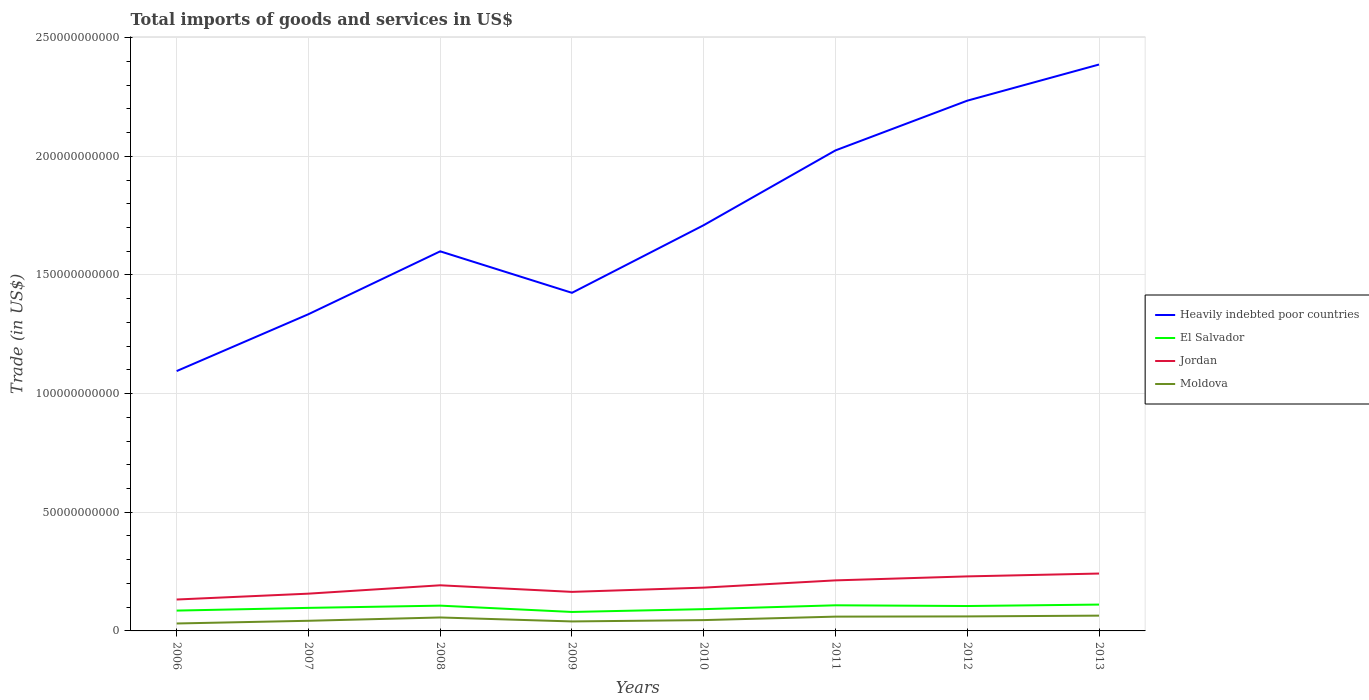Does the line corresponding to Heavily indebted poor countries intersect with the line corresponding to El Salvador?
Offer a terse response. No. Across all years, what is the maximum total imports of goods and services in Moldova?
Offer a very short reply. 3.13e+09. What is the total total imports of goods and services in Moldova in the graph?
Ensure brevity in your answer.  2.78e+08. What is the difference between the highest and the second highest total imports of goods and services in Jordan?
Your response must be concise. 1.09e+1. How many lines are there?
Offer a terse response. 4. How many years are there in the graph?
Provide a succinct answer. 8. Are the values on the major ticks of Y-axis written in scientific E-notation?
Provide a succinct answer. No. Does the graph contain grids?
Your answer should be very brief. Yes. Where does the legend appear in the graph?
Offer a very short reply. Center right. What is the title of the graph?
Provide a short and direct response. Total imports of goods and services in US$. Does "Middle East & North Africa (developing only)" appear as one of the legend labels in the graph?
Provide a succinct answer. No. What is the label or title of the Y-axis?
Provide a succinct answer. Trade (in US$). What is the Trade (in US$) in Heavily indebted poor countries in 2006?
Give a very brief answer. 1.09e+11. What is the Trade (in US$) in El Salvador in 2006?
Offer a very short reply. 8.56e+09. What is the Trade (in US$) of Jordan in 2006?
Your answer should be very brief. 1.32e+1. What is the Trade (in US$) in Moldova in 2006?
Provide a short and direct response. 3.13e+09. What is the Trade (in US$) in Heavily indebted poor countries in 2007?
Your answer should be very brief. 1.33e+11. What is the Trade (in US$) in El Salvador in 2007?
Your answer should be compact. 9.71e+09. What is the Trade (in US$) in Jordan in 2007?
Make the answer very short. 1.57e+1. What is the Trade (in US$) of Moldova in 2007?
Ensure brevity in your answer.  4.28e+09. What is the Trade (in US$) in Heavily indebted poor countries in 2008?
Your response must be concise. 1.60e+11. What is the Trade (in US$) of El Salvador in 2008?
Offer a very short reply. 1.07e+1. What is the Trade (in US$) in Jordan in 2008?
Your response must be concise. 1.92e+1. What is the Trade (in US$) of Moldova in 2008?
Offer a very short reply. 5.67e+09. What is the Trade (in US$) of Heavily indebted poor countries in 2009?
Offer a very short reply. 1.42e+11. What is the Trade (in US$) of El Salvador in 2009?
Provide a succinct answer. 7.99e+09. What is the Trade (in US$) of Jordan in 2009?
Your answer should be very brief. 1.65e+1. What is the Trade (in US$) in Moldova in 2009?
Ensure brevity in your answer.  4.00e+09. What is the Trade (in US$) of Heavily indebted poor countries in 2010?
Give a very brief answer. 1.71e+11. What is the Trade (in US$) of El Salvador in 2010?
Offer a terse response. 9.18e+09. What is the Trade (in US$) in Jordan in 2010?
Offer a very short reply. 1.82e+1. What is the Trade (in US$) in Moldova in 2010?
Offer a very short reply. 4.56e+09. What is the Trade (in US$) of Heavily indebted poor countries in 2011?
Keep it short and to the point. 2.02e+11. What is the Trade (in US$) in El Salvador in 2011?
Your response must be concise. 1.08e+1. What is the Trade (in US$) of Jordan in 2011?
Your answer should be very brief. 2.13e+1. What is the Trade (in US$) in Moldova in 2011?
Offer a very short reply. 6.02e+09. What is the Trade (in US$) of Heavily indebted poor countries in 2012?
Make the answer very short. 2.23e+11. What is the Trade (in US$) in El Salvador in 2012?
Offer a very short reply. 1.05e+1. What is the Trade (in US$) in Jordan in 2012?
Give a very brief answer. 2.30e+1. What is the Trade (in US$) of Moldova in 2012?
Your answer should be compact. 6.11e+09. What is the Trade (in US$) of Heavily indebted poor countries in 2013?
Your answer should be very brief. 2.39e+11. What is the Trade (in US$) of El Salvador in 2013?
Your answer should be compact. 1.11e+1. What is the Trade (in US$) in Jordan in 2013?
Give a very brief answer. 2.42e+1. What is the Trade (in US$) in Moldova in 2013?
Ensure brevity in your answer.  6.44e+09. Across all years, what is the maximum Trade (in US$) of Heavily indebted poor countries?
Offer a very short reply. 2.39e+11. Across all years, what is the maximum Trade (in US$) in El Salvador?
Your response must be concise. 1.11e+1. Across all years, what is the maximum Trade (in US$) of Jordan?
Your answer should be very brief. 2.42e+1. Across all years, what is the maximum Trade (in US$) in Moldova?
Ensure brevity in your answer.  6.44e+09. Across all years, what is the minimum Trade (in US$) in Heavily indebted poor countries?
Provide a short and direct response. 1.09e+11. Across all years, what is the minimum Trade (in US$) in El Salvador?
Make the answer very short. 7.99e+09. Across all years, what is the minimum Trade (in US$) in Jordan?
Offer a terse response. 1.32e+1. Across all years, what is the minimum Trade (in US$) of Moldova?
Ensure brevity in your answer.  3.13e+09. What is the total Trade (in US$) of Heavily indebted poor countries in the graph?
Offer a very short reply. 1.38e+12. What is the total Trade (in US$) in El Salvador in the graph?
Your answer should be very brief. 7.85e+1. What is the total Trade (in US$) of Jordan in the graph?
Offer a very short reply. 1.51e+11. What is the total Trade (in US$) in Moldova in the graph?
Keep it short and to the point. 4.02e+1. What is the difference between the Trade (in US$) in Heavily indebted poor countries in 2006 and that in 2007?
Your answer should be compact. -2.40e+1. What is the difference between the Trade (in US$) in El Salvador in 2006 and that in 2007?
Your answer should be compact. -1.15e+09. What is the difference between the Trade (in US$) in Jordan in 2006 and that in 2007?
Give a very brief answer. -2.47e+09. What is the difference between the Trade (in US$) of Moldova in 2006 and that in 2007?
Keep it short and to the point. -1.14e+09. What is the difference between the Trade (in US$) in Heavily indebted poor countries in 2006 and that in 2008?
Your answer should be compact. -5.05e+1. What is the difference between the Trade (in US$) in El Salvador in 2006 and that in 2008?
Provide a succinct answer. -2.09e+09. What is the difference between the Trade (in US$) in Jordan in 2006 and that in 2008?
Your answer should be compact. -6.00e+09. What is the difference between the Trade (in US$) in Moldova in 2006 and that in 2008?
Give a very brief answer. -2.54e+09. What is the difference between the Trade (in US$) of Heavily indebted poor countries in 2006 and that in 2009?
Make the answer very short. -3.30e+1. What is the difference between the Trade (in US$) of El Salvador in 2006 and that in 2009?
Give a very brief answer. 5.74e+08. What is the difference between the Trade (in US$) in Jordan in 2006 and that in 2009?
Ensure brevity in your answer.  -3.22e+09. What is the difference between the Trade (in US$) in Moldova in 2006 and that in 2009?
Provide a short and direct response. -8.65e+08. What is the difference between the Trade (in US$) in Heavily indebted poor countries in 2006 and that in 2010?
Ensure brevity in your answer.  -6.15e+1. What is the difference between the Trade (in US$) of El Salvador in 2006 and that in 2010?
Make the answer very short. -6.12e+08. What is the difference between the Trade (in US$) of Jordan in 2006 and that in 2010?
Offer a very short reply. -5.01e+09. What is the difference between the Trade (in US$) in Moldova in 2006 and that in 2010?
Give a very brief answer. -1.43e+09. What is the difference between the Trade (in US$) in Heavily indebted poor countries in 2006 and that in 2011?
Your answer should be compact. -9.30e+1. What is the difference between the Trade (in US$) of El Salvador in 2006 and that in 2011?
Offer a very short reply. -2.23e+09. What is the difference between the Trade (in US$) in Jordan in 2006 and that in 2011?
Your answer should be compact. -8.07e+09. What is the difference between the Trade (in US$) of Moldova in 2006 and that in 2011?
Offer a very short reply. -2.89e+09. What is the difference between the Trade (in US$) of Heavily indebted poor countries in 2006 and that in 2012?
Give a very brief answer. -1.14e+11. What is the difference between the Trade (in US$) of El Salvador in 2006 and that in 2012?
Provide a succinct answer. -1.93e+09. What is the difference between the Trade (in US$) in Jordan in 2006 and that in 2012?
Your answer should be very brief. -9.74e+09. What is the difference between the Trade (in US$) of Moldova in 2006 and that in 2012?
Your answer should be very brief. -2.98e+09. What is the difference between the Trade (in US$) in Heavily indebted poor countries in 2006 and that in 2013?
Provide a succinct answer. -1.29e+11. What is the difference between the Trade (in US$) in El Salvador in 2006 and that in 2013?
Your answer should be compact. -2.53e+09. What is the difference between the Trade (in US$) of Jordan in 2006 and that in 2013?
Provide a succinct answer. -1.09e+1. What is the difference between the Trade (in US$) of Moldova in 2006 and that in 2013?
Keep it short and to the point. -3.30e+09. What is the difference between the Trade (in US$) in Heavily indebted poor countries in 2007 and that in 2008?
Ensure brevity in your answer.  -2.65e+1. What is the difference between the Trade (in US$) in El Salvador in 2007 and that in 2008?
Keep it short and to the point. -9.41e+08. What is the difference between the Trade (in US$) in Jordan in 2007 and that in 2008?
Keep it short and to the point. -3.53e+09. What is the difference between the Trade (in US$) in Moldova in 2007 and that in 2008?
Offer a very short reply. -1.39e+09. What is the difference between the Trade (in US$) of Heavily indebted poor countries in 2007 and that in 2009?
Ensure brevity in your answer.  -9.01e+09. What is the difference between the Trade (in US$) in El Salvador in 2007 and that in 2009?
Provide a succinct answer. 1.72e+09. What is the difference between the Trade (in US$) in Jordan in 2007 and that in 2009?
Your answer should be compact. -7.53e+08. What is the difference between the Trade (in US$) in Moldova in 2007 and that in 2009?
Give a very brief answer. 2.78e+08. What is the difference between the Trade (in US$) of Heavily indebted poor countries in 2007 and that in 2010?
Provide a succinct answer. -3.75e+1. What is the difference between the Trade (in US$) of El Salvador in 2007 and that in 2010?
Ensure brevity in your answer.  5.33e+08. What is the difference between the Trade (in US$) in Jordan in 2007 and that in 2010?
Offer a terse response. -2.54e+09. What is the difference between the Trade (in US$) of Moldova in 2007 and that in 2010?
Offer a terse response. -2.89e+08. What is the difference between the Trade (in US$) of Heavily indebted poor countries in 2007 and that in 2011?
Provide a succinct answer. -6.90e+1. What is the difference between the Trade (in US$) of El Salvador in 2007 and that in 2011?
Offer a terse response. -1.09e+09. What is the difference between the Trade (in US$) in Jordan in 2007 and that in 2011?
Your response must be concise. -5.60e+09. What is the difference between the Trade (in US$) in Moldova in 2007 and that in 2011?
Ensure brevity in your answer.  -1.75e+09. What is the difference between the Trade (in US$) of Heavily indebted poor countries in 2007 and that in 2012?
Make the answer very short. -9.00e+1. What is the difference between the Trade (in US$) of El Salvador in 2007 and that in 2012?
Provide a succinct answer. -7.87e+08. What is the difference between the Trade (in US$) in Jordan in 2007 and that in 2012?
Offer a very short reply. -7.28e+09. What is the difference between the Trade (in US$) of Moldova in 2007 and that in 2012?
Give a very brief answer. -1.84e+09. What is the difference between the Trade (in US$) in Heavily indebted poor countries in 2007 and that in 2013?
Offer a terse response. -1.05e+11. What is the difference between the Trade (in US$) in El Salvador in 2007 and that in 2013?
Keep it short and to the point. -1.39e+09. What is the difference between the Trade (in US$) of Jordan in 2007 and that in 2013?
Offer a very short reply. -8.47e+09. What is the difference between the Trade (in US$) of Moldova in 2007 and that in 2013?
Your answer should be compact. -2.16e+09. What is the difference between the Trade (in US$) in Heavily indebted poor countries in 2008 and that in 2009?
Offer a terse response. 1.75e+1. What is the difference between the Trade (in US$) of El Salvador in 2008 and that in 2009?
Give a very brief answer. 2.66e+09. What is the difference between the Trade (in US$) of Jordan in 2008 and that in 2009?
Provide a succinct answer. 2.77e+09. What is the difference between the Trade (in US$) of Moldova in 2008 and that in 2009?
Make the answer very short. 1.67e+09. What is the difference between the Trade (in US$) in Heavily indebted poor countries in 2008 and that in 2010?
Provide a short and direct response. -1.10e+1. What is the difference between the Trade (in US$) in El Salvador in 2008 and that in 2010?
Provide a short and direct response. 1.47e+09. What is the difference between the Trade (in US$) of Jordan in 2008 and that in 2010?
Keep it short and to the point. 9.86e+08. What is the difference between the Trade (in US$) in Moldova in 2008 and that in 2010?
Ensure brevity in your answer.  1.10e+09. What is the difference between the Trade (in US$) in Heavily indebted poor countries in 2008 and that in 2011?
Provide a succinct answer. -4.25e+1. What is the difference between the Trade (in US$) in El Salvador in 2008 and that in 2011?
Make the answer very short. -1.46e+08. What is the difference between the Trade (in US$) in Jordan in 2008 and that in 2011?
Provide a succinct answer. -2.07e+09. What is the difference between the Trade (in US$) in Moldova in 2008 and that in 2011?
Give a very brief answer. -3.54e+08. What is the difference between the Trade (in US$) in Heavily indebted poor countries in 2008 and that in 2012?
Offer a terse response. -6.35e+1. What is the difference between the Trade (in US$) of El Salvador in 2008 and that in 2012?
Provide a succinct answer. 1.55e+08. What is the difference between the Trade (in US$) of Jordan in 2008 and that in 2012?
Offer a terse response. -3.75e+09. What is the difference between the Trade (in US$) of Moldova in 2008 and that in 2012?
Your response must be concise. -4.47e+08. What is the difference between the Trade (in US$) in Heavily indebted poor countries in 2008 and that in 2013?
Provide a succinct answer. -7.87e+1. What is the difference between the Trade (in US$) of El Salvador in 2008 and that in 2013?
Provide a short and direct response. -4.48e+08. What is the difference between the Trade (in US$) in Jordan in 2008 and that in 2013?
Your response must be concise. -4.95e+09. What is the difference between the Trade (in US$) of Moldova in 2008 and that in 2013?
Give a very brief answer. -7.68e+08. What is the difference between the Trade (in US$) in Heavily indebted poor countries in 2009 and that in 2010?
Give a very brief answer. -2.85e+1. What is the difference between the Trade (in US$) in El Salvador in 2009 and that in 2010?
Your response must be concise. -1.19e+09. What is the difference between the Trade (in US$) of Jordan in 2009 and that in 2010?
Keep it short and to the point. -1.79e+09. What is the difference between the Trade (in US$) in Moldova in 2009 and that in 2010?
Your response must be concise. -5.67e+08. What is the difference between the Trade (in US$) in Heavily indebted poor countries in 2009 and that in 2011?
Keep it short and to the point. -6.00e+1. What is the difference between the Trade (in US$) of El Salvador in 2009 and that in 2011?
Keep it short and to the point. -2.81e+09. What is the difference between the Trade (in US$) in Jordan in 2009 and that in 2011?
Provide a short and direct response. -4.85e+09. What is the difference between the Trade (in US$) in Moldova in 2009 and that in 2011?
Your response must be concise. -2.02e+09. What is the difference between the Trade (in US$) of Heavily indebted poor countries in 2009 and that in 2012?
Ensure brevity in your answer.  -8.10e+1. What is the difference between the Trade (in US$) of El Salvador in 2009 and that in 2012?
Your answer should be very brief. -2.51e+09. What is the difference between the Trade (in US$) in Jordan in 2009 and that in 2012?
Your answer should be compact. -6.52e+09. What is the difference between the Trade (in US$) in Moldova in 2009 and that in 2012?
Offer a very short reply. -2.12e+09. What is the difference between the Trade (in US$) in Heavily indebted poor countries in 2009 and that in 2013?
Make the answer very short. -9.62e+1. What is the difference between the Trade (in US$) of El Salvador in 2009 and that in 2013?
Provide a succinct answer. -3.11e+09. What is the difference between the Trade (in US$) of Jordan in 2009 and that in 2013?
Ensure brevity in your answer.  -7.72e+09. What is the difference between the Trade (in US$) of Moldova in 2009 and that in 2013?
Offer a terse response. -2.44e+09. What is the difference between the Trade (in US$) of Heavily indebted poor countries in 2010 and that in 2011?
Your answer should be very brief. -3.15e+1. What is the difference between the Trade (in US$) of El Salvador in 2010 and that in 2011?
Make the answer very short. -1.62e+09. What is the difference between the Trade (in US$) of Jordan in 2010 and that in 2011?
Provide a short and direct response. -3.06e+09. What is the difference between the Trade (in US$) in Moldova in 2010 and that in 2011?
Offer a terse response. -1.46e+09. What is the difference between the Trade (in US$) of Heavily indebted poor countries in 2010 and that in 2012?
Your answer should be very brief. -5.25e+1. What is the difference between the Trade (in US$) of El Salvador in 2010 and that in 2012?
Give a very brief answer. -1.32e+09. What is the difference between the Trade (in US$) of Jordan in 2010 and that in 2012?
Your answer should be very brief. -4.73e+09. What is the difference between the Trade (in US$) of Moldova in 2010 and that in 2012?
Provide a succinct answer. -1.55e+09. What is the difference between the Trade (in US$) in Heavily indebted poor countries in 2010 and that in 2013?
Your answer should be compact. -6.77e+1. What is the difference between the Trade (in US$) in El Salvador in 2010 and that in 2013?
Offer a very short reply. -1.92e+09. What is the difference between the Trade (in US$) of Jordan in 2010 and that in 2013?
Make the answer very short. -5.93e+09. What is the difference between the Trade (in US$) of Moldova in 2010 and that in 2013?
Keep it short and to the point. -1.87e+09. What is the difference between the Trade (in US$) in Heavily indebted poor countries in 2011 and that in 2012?
Your response must be concise. -2.09e+1. What is the difference between the Trade (in US$) in El Salvador in 2011 and that in 2012?
Your answer should be very brief. 3.01e+08. What is the difference between the Trade (in US$) of Jordan in 2011 and that in 2012?
Offer a terse response. -1.67e+09. What is the difference between the Trade (in US$) of Moldova in 2011 and that in 2012?
Offer a terse response. -9.38e+07. What is the difference between the Trade (in US$) in Heavily indebted poor countries in 2011 and that in 2013?
Make the answer very short. -3.62e+1. What is the difference between the Trade (in US$) of El Salvador in 2011 and that in 2013?
Your response must be concise. -3.01e+08. What is the difference between the Trade (in US$) in Jordan in 2011 and that in 2013?
Your response must be concise. -2.87e+09. What is the difference between the Trade (in US$) in Moldova in 2011 and that in 2013?
Ensure brevity in your answer.  -4.15e+08. What is the difference between the Trade (in US$) of Heavily indebted poor countries in 2012 and that in 2013?
Your response must be concise. -1.52e+1. What is the difference between the Trade (in US$) in El Salvador in 2012 and that in 2013?
Offer a very short reply. -6.02e+08. What is the difference between the Trade (in US$) in Jordan in 2012 and that in 2013?
Offer a terse response. -1.20e+09. What is the difference between the Trade (in US$) in Moldova in 2012 and that in 2013?
Provide a succinct answer. -3.21e+08. What is the difference between the Trade (in US$) of Heavily indebted poor countries in 2006 and the Trade (in US$) of El Salvador in 2007?
Your response must be concise. 9.98e+1. What is the difference between the Trade (in US$) in Heavily indebted poor countries in 2006 and the Trade (in US$) in Jordan in 2007?
Provide a short and direct response. 9.38e+1. What is the difference between the Trade (in US$) in Heavily indebted poor countries in 2006 and the Trade (in US$) in Moldova in 2007?
Ensure brevity in your answer.  1.05e+11. What is the difference between the Trade (in US$) of El Salvador in 2006 and the Trade (in US$) of Jordan in 2007?
Provide a succinct answer. -7.14e+09. What is the difference between the Trade (in US$) in El Salvador in 2006 and the Trade (in US$) in Moldova in 2007?
Your response must be concise. 4.29e+09. What is the difference between the Trade (in US$) in Jordan in 2006 and the Trade (in US$) in Moldova in 2007?
Give a very brief answer. 8.96e+09. What is the difference between the Trade (in US$) of Heavily indebted poor countries in 2006 and the Trade (in US$) of El Salvador in 2008?
Your response must be concise. 9.88e+1. What is the difference between the Trade (in US$) in Heavily indebted poor countries in 2006 and the Trade (in US$) in Jordan in 2008?
Offer a very short reply. 9.03e+1. What is the difference between the Trade (in US$) in Heavily indebted poor countries in 2006 and the Trade (in US$) in Moldova in 2008?
Keep it short and to the point. 1.04e+11. What is the difference between the Trade (in US$) of El Salvador in 2006 and the Trade (in US$) of Jordan in 2008?
Make the answer very short. -1.07e+1. What is the difference between the Trade (in US$) of El Salvador in 2006 and the Trade (in US$) of Moldova in 2008?
Provide a short and direct response. 2.90e+09. What is the difference between the Trade (in US$) in Jordan in 2006 and the Trade (in US$) in Moldova in 2008?
Provide a succinct answer. 7.56e+09. What is the difference between the Trade (in US$) of Heavily indebted poor countries in 2006 and the Trade (in US$) of El Salvador in 2009?
Make the answer very short. 1.02e+11. What is the difference between the Trade (in US$) in Heavily indebted poor countries in 2006 and the Trade (in US$) in Jordan in 2009?
Give a very brief answer. 9.30e+1. What is the difference between the Trade (in US$) in Heavily indebted poor countries in 2006 and the Trade (in US$) in Moldova in 2009?
Offer a very short reply. 1.05e+11. What is the difference between the Trade (in US$) of El Salvador in 2006 and the Trade (in US$) of Jordan in 2009?
Your answer should be compact. -7.89e+09. What is the difference between the Trade (in US$) of El Salvador in 2006 and the Trade (in US$) of Moldova in 2009?
Your answer should be compact. 4.57e+09. What is the difference between the Trade (in US$) in Jordan in 2006 and the Trade (in US$) in Moldova in 2009?
Provide a succinct answer. 9.23e+09. What is the difference between the Trade (in US$) in Heavily indebted poor countries in 2006 and the Trade (in US$) in El Salvador in 2010?
Your answer should be very brief. 1.00e+11. What is the difference between the Trade (in US$) of Heavily indebted poor countries in 2006 and the Trade (in US$) of Jordan in 2010?
Make the answer very short. 9.13e+1. What is the difference between the Trade (in US$) in Heavily indebted poor countries in 2006 and the Trade (in US$) in Moldova in 2010?
Offer a terse response. 1.05e+11. What is the difference between the Trade (in US$) of El Salvador in 2006 and the Trade (in US$) of Jordan in 2010?
Your answer should be compact. -9.68e+09. What is the difference between the Trade (in US$) of El Salvador in 2006 and the Trade (in US$) of Moldova in 2010?
Make the answer very short. 4.00e+09. What is the difference between the Trade (in US$) of Jordan in 2006 and the Trade (in US$) of Moldova in 2010?
Ensure brevity in your answer.  8.67e+09. What is the difference between the Trade (in US$) in Heavily indebted poor countries in 2006 and the Trade (in US$) in El Salvador in 2011?
Offer a very short reply. 9.87e+1. What is the difference between the Trade (in US$) of Heavily indebted poor countries in 2006 and the Trade (in US$) of Jordan in 2011?
Your answer should be compact. 8.82e+1. What is the difference between the Trade (in US$) of Heavily indebted poor countries in 2006 and the Trade (in US$) of Moldova in 2011?
Ensure brevity in your answer.  1.03e+11. What is the difference between the Trade (in US$) of El Salvador in 2006 and the Trade (in US$) of Jordan in 2011?
Keep it short and to the point. -1.27e+1. What is the difference between the Trade (in US$) of El Salvador in 2006 and the Trade (in US$) of Moldova in 2011?
Offer a very short reply. 2.54e+09. What is the difference between the Trade (in US$) of Jordan in 2006 and the Trade (in US$) of Moldova in 2011?
Offer a terse response. 7.21e+09. What is the difference between the Trade (in US$) in Heavily indebted poor countries in 2006 and the Trade (in US$) in El Salvador in 2012?
Keep it short and to the point. 9.90e+1. What is the difference between the Trade (in US$) of Heavily indebted poor countries in 2006 and the Trade (in US$) of Jordan in 2012?
Give a very brief answer. 8.65e+1. What is the difference between the Trade (in US$) in Heavily indebted poor countries in 2006 and the Trade (in US$) in Moldova in 2012?
Your answer should be compact. 1.03e+11. What is the difference between the Trade (in US$) of El Salvador in 2006 and the Trade (in US$) of Jordan in 2012?
Make the answer very short. -1.44e+1. What is the difference between the Trade (in US$) of El Salvador in 2006 and the Trade (in US$) of Moldova in 2012?
Make the answer very short. 2.45e+09. What is the difference between the Trade (in US$) in Jordan in 2006 and the Trade (in US$) in Moldova in 2012?
Your answer should be very brief. 7.12e+09. What is the difference between the Trade (in US$) of Heavily indebted poor countries in 2006 and the Trade (in US$) of El Salvador in 2013?
Provide a short and direct response. 9.84e+1. What is the difference between the Trade (in US$) in Heavily indebted poor countries in 2006 and the Trade (in US$) in Jordan in 2013?
Keep it short and to the point. 8.53e+1. What is the difference between the Trade (in US$) in Heavily indebted poor countries in 2006 and the Trade (in US$) in Moldova in 2013?
Give a very brief answer. 1.03e+11. What is the difference between the Trade (in US$) of El Salvador in 2006 and the Trade (in US$) of Jordan in 2013?
Keep it short and to the point. -1.56e+1. What is the difference between the Trade (in US$) of El Salvador in 2006 and the Trade (in US$) of Moldova in 2013?
Give a very brief answer. 2.13e+09. What is the difference between the Trade (in US$) in Jordan in 2006 and the Trade (in US$) in Moldova in 2013?
Provide a short and direct response. 6.80e+09. What is the difference between the Trade (in US$) in Heavily indebted poor countries in 2007 and the Trade (in US$) in El Salvador in 2008?
Provide a short and direct response. 1.23e+11. What is the difference between the Trade (in US$) in Heavily indebted poor countries in 2007 and the Trade (in US$) in Jordan in 2008?
Give a very brief answer. 1.14e+11. What is the difference between the Trade (in US$) of Heavily indebted poor countries in 2007 and the Trade (in US$) of Moldova in 2008?
Offer a terse response. 1.28e+11. What is the difference between the Trade (in US$) of El Salvador in 2007 and the Trade (in US$) of Jordan in 2008?
Make the answer very short. -9.52e+09. What is the difference between the Trade (in US$) in El Salvador in 2007 and the Trade (in US$) in Moldova in 2008?
Offer a terse response. 4.04e+09. What is the difference between the Trade (in US$) of Jordan in 2007 and the Trade (in US$) of Moldova in 2008?
Your answer should be compact. 1.00e+1. What is the difference between the Trade (in US$) of Heavily indebted poor countries in 2007 and the Trade (in US$) of El Salvador in 2009?
Your answer should be very brief. 1.25e+11. What is the difference between the Trade (in US$) in Heavily indebted poor countries in 2007 and the Trade (in US$) in Jordan in 2009?
Ensure brevity in your answer.  1.17e+11. What is the difference between the Trade (in US$) of Heavily indebted poor countries in 2007 and the Trade (in US$) of Moldova in 2009?
Make the answer very short. 1.29e+11. What is the difference between the Trade (in US$) in El Salvador in 2007 and the Trade (in US$) in Jordan in 2009?
Provide a short and direct response. -6.74e+09. What is the difference between the Trade (in US$) in El Salvador in 2007 and the Trade (in US$) in Moldova in 2009?
Your response must be concise. 5.71e+09. What is the difference between the Trade (in US$) of Jordan in 2007 and the Trade (in US$) of Moldova in 2009?
Make the answer very short. 1.17e+1. What is the difference between the Trade (in US$) of Heavily indebted poor countries in 2007 and the Trade (in US$) of El Salvador in 2010?
Make the answer very short. 1.24e+11. What is the difference between the Trade (in US$) in Heavily indebted poor countries in 2007 and the Trade (in US$) in Jordan in 2010?
Give a very brief answer. 1.15e+11. What is the difference between the Trade (in US$) of Heavily indebted poor countries in 2007 and the Trade (in US$) of Moldova in 2010?
Offer a terse response. 1.29e+11. What is the difference between the Trade (in US$) of El Salvador in 2007 and the Trade (in US$) of Jordan in 2010?
Your response must be concise. -8.53e+09. What is the difference between the Trade (in US$) of El Salvador in 2007 and the Trade (in US$) of Moldova in 2010?
Provide a succinct answer. 5.14e+09. What is the difference between the Trade (in US$) of Jordan in 2007 and the Trade (in US$) of Moldova in 2010?
Ensure brevity in your answer.  1.11e+1. What is the difference between the Trade (in US$) of Heavily indebted poor countries in 2007 and the Trade (in US$) of El Salvador in 2011?
Make the answer very short. 1.23e+11. What is the difference between the Trade (in US$) of Heavily indebted poor countries in 2007 and the Trade (in US$) of Jordan in 2011?
Offer a terse response. 1.12e+11. What is the difference between the Trade (in US$) of Heavily indebted poor countries in 2007 and the Trade (in US$) of Moldova in 2011?
Offer a terse response. 1.27e+11. What is the difference between the Trade (in US$) of El Salvador in 2007 and the Trade (in US$) of Jordan in 2011?
Make the answer very short. -1.16e+1. What is the difference between the Trade (in US$) in El Salvador in 2007 and the Trade (in US$) in Moldova in 2011?
Provide a short and direct response. 3.69e+09. What is the difference between the Trade (in US$) in Jordan in 2007 and the Trade (in US$) in Moldova in 2011?
Provide a short and direct response. 9.68e+09. What is the difference between the Trade (in US$) in Heavily indebted poor countries in 2007 and the Trade (in US$) in El Salvador in 2012?
Your answer should be compact. 1.23e+11. What is the difference between the Trade (in US$) in Heavily indebted poor countries in 2007 and the Trade (in US$) in Jordan in 2012?
Your answer should be compact. 1.10e+11. What is the difference between the Trade (in US$) of Heavily indebted poor countries in 2007 and the Trade (in US$) of Moldova in 2012?
Offer a terse response. 1.27e+11. What is the difference between the Trade (in US$) of El Salvador in 2007 and the Trade (in US$) of Jordan in 2012?
Ensure brevity in your answer.  -1.33e+1. What is the difference between the Trade (in US$) of El Salvador in 2007 and the Trade (in US$) of Moldova in 2012?
Offer a terse response. 3.59e+09. What is the difference between the Trade (in US$) in Jordan in 2007 and the Trade (in US$) in Moldova in 2012?
Ensure brevity in your answer.  9.59e+09. What is the difference between the Trade (in US$) of Heavily indebted poor countries in 2007 and the Trade (in US$) of El Salvador in 2013?
Make the answer very short. 1.22e+11. What is the difference between the Trade (in US$) of Heavily indebted poor countries in 2007 and the Trade (in US$) of Jordan in 2013?
Ensure brevity in your answer.  1.09e+11. What is the difference between the Trade (in US$) of Heavily indebted poor countries in 2007 and the Trade (in US$) of Moldova in 2013?
Offer a very short reply. 1.27e+11. What is the difference between the Trade (in US$) in El Salvador in 2007 and the Trade (in US$) in Jordan in 2013?
Offer a terse response. -1.45e+1. What is the difference between the Trade (in US$) of El Salvador in 2007 and the Trade (in US$) of Moldova in 2013?
Your response must be concise. 3.27e+09. What is the difference between the Trade (in US$) in Jordan in 2007 and the Trade (in US$) in Moldova in 2013?
Keep it short and to the point. 9.26e+09. What is the difference between the Trade (in US$) of Heavily indebted poor countries in 2008 and the Trade (in US$) of El Salvador in 2009?
Provide a short and direct response. 1.52e+11. What is the difference between the Trade (in US$) in Heavily indebted poor countries in 2008 and the Trade (in US$) in Jordan in 2009?
Offer a terse response. 1.43e+11. What is the difference between the Trade (in US$) in Heavily indebted poor countries in 2008 and the Trade (in US$) in Moldova in 2009?
Provide a succinct answer. 1.56e+11. What is the difference between the Trade (in US$) in El Salvador in 2008 and the Trade (in US$) in Jordan in 2009?
Your response must be concise. -5.80e+09. What is the difference between the Trade (in US$) in El Salvador in 2008 and the Trade (in US$) in Moldova in 2009?
Your answer should be compact. 6.65e+09. What is the difference between the Trade (in US$) of Jordan in 2008 and the Trade (in US$) of Moldova in 2009?
Your answer should be compact. 1.52e+1. What is the difference between the Trade (in US$) in Heavily indebted poor countries in 2008 and the Trade (in US$) in El Salvador in 2010?
Your answer should be compact. 1.51e+11. What is the difference between the Trade (in US$) of Heavily indebted poor countries in 2008 and the Trade (in US$) of Jordan in 2010?
Your answer should be compact. 1.42e+11. What is the difference between the Trade (in US$) in Heavily indebted poor countries in 2008 and the Trade (in US$) in Moldova in 2010?
Offer a very short reply. 1.55e+11. What is the difference between the Trade (in US$) in El Salvador in 2008 and the Trade (in US$) in Jordan in 2010?
Your response must be concise. -7.59e+09. What is the difference between the Trade (in US$) in El Salvador in 2008 and the Trade (in US$) in Moldova in 2010?
Give a very brief answer. 6.09e+09. What is the difference between the Trade (in US$) in Jordan in 2008 and the Trade (in US$) in Moldova in 2010?
Keep it short and to the point. 1.47e+1. What is the difference between the Trade (in US$) in Heavily indebted poor countries in 2008 and the Trade (in US$) in El Salvador in 2011?
Give a very brief answer. 1.49e+11. What is the difference between the Trade (in US$) in Heavily indebted poor countries in 2008 and the Trade (in US$) in Jordan in 2011?
Provide a succinct answer. 1.39e+11. What is the difference between the Trade (in US$) of Heavily indebted poor countries in 2008 and the Trade (in US$) of Moldova in 2011?
Your response must be concise. 1.54e+11. What is the difference between the Trade (in US$) in El Salvador in 2008 and the Trade (in US$) in Jordan in 2011?
Offer a terse response. -1.07e+1. What is the difference between the Trade (in US$) of El Salvador in 2008 and the Trade (in US$) of Moldova in 2011?
Keep it short and to the point. 4.63e+09. What is the difference between the Trade (in US$) in Jordan in 2008 and the Trade (in US$) in Moldova in 2011?
Provide a succinct answer. 1.32e+1. What is the difference between the Trade (in US$) of Heavily indebted poor countries in 2008 and the Trade (in US$) of El Salvador in 2012?
Provide a succinct answer. 1.49e+11. What is the difference between the Trade (in US$) in Heavily indebted poor countries in 2008 and the Trade (in US$) in Jordan in 2012?
Offer a terse response. 1.37e+11. What is the difference between the Trade (in US$) in Heavily indebted poor countries in 2008 and the Trade (in US$) in Moldova in 2012?
Your answer should be compact. 1.54e+11. What is the difference between the Trade (in US$) of El Salvador in 2008 and the Trade (in US$) of Jordan in 2012?
Provide a succinct answer. -1.23e+1. What is the difference between the Trade (in US$) in El Salvador in 2008 and the Trade (in US$) in Moldova in 2012?
Make the answer very short. 4.54e+09. What is the difference between the Trade (in US$) of Jordan in 2008 and the Trade (in US$) of Moldova in 2012?
Give a very brief answer. 1.31e+1. What is the difference between the Trade (in US$) in Heavily indebted poor countries in 2008 and the Trade (in US$) in El Salvador in 2013?
Provide a short and direct response. 1.49e+11. What is the difference between the Trade (in US$) in Heavily indebted poor countries in 2008 and the Trade (in US$) in Jordan in 2013?
Provide a short and direct response. 1.36e+11. What is the difference between the Trade (in US$) in Heavily indebted poor countries in 2008 and the Trade (in US$) in Moldova in 2013?
Your response must be concise. 1.54e+11. What is the difference between the Trade (in US$) of El Salvador in 2008 and the Trade (in US$) of Jordan in 2013?
Keep it short and to the point. -1.35e+1. What is the difference between the Trade (in US$) in El Salvador in 2008 and the Trade (in US$) in Moldova in 2013?
Provide a succinct answer. 4.22e+09. What is the difference between the Trade (in US$) in Jordan in 2008 and the Trade (in US$) in Moldova in 2013?
Offer a very short reply. 1.28e+1. What is the difference between the Trade (in US$) of Heavily indebted poor countries in 2009 and the Trade (in US$) of El Salvador in 2010?
Your answer should be very brief. 1.33e+11. What is the difference between the Trade (in US$) of Heavily indebted poor countries in 2009 and the Trade (in US$) of Jordan in 2010?
Keep it short and to the point. 1.24e+11. What is the difference between the Trade (in US$) in Heavily indebted poor countries in 2009 and the Trade (in US$) in Moldova in 2010?
Keep it short and to the point. 1.38e+11. What is the difference between the Trade (in US$) of El Salvador in 2009 and the Trade (in US$) of Jordan in 2010?
Offer a terse response. -1.03e+1. What is the difference between the Trade (in US$) of El Salvador in 2009 and the Trade (in US$) of Moldova in 2010?
Your response must be concise. 3.43e+09. What is the difference between the Trade (in US$) in Jordan in 2009 and the Trade (in US$) in Moldova in 2010?
Your response must be concise. 1.19e+1. What is the difference between the Trade (in US$) of Heavily indebted poor countries in 2009 and the Trade (in US$) of El Salvador in 2011?
Provide a succinct answer. 1.32e+11. What is the difference between the Trade (in US$) of Heavily indebted poor countries in 2009 and the Trade (in US$) of Jordan in 2011?
Offer a terse response. 1.21e+11. What is the difference between the Trade (in US$) of Heavily indebted poor countries in 2009 and the Trade (in US$) of Moldova in 2011?
Ensure brevity in your answer.  1.36e+11. What is the difference between the Trade (in US$) in El Salvador in 2009 and the Trade (in US$) in Jordan in 2011?
Provide a succinct answer. -1.33e+1. What is the difference between the Trade (in US$) in El Salvador in 2009 and the Trade (in US$) in Moldova in 2011?
Offer a very short reply. 1.97e+09. What is the difference between the Trade (in US$) in Jordan in 2009 and the Trade (in US$) in Moldova in 2011?
Make the answer very short. 1.04e+1. What is the difference between the Trade (in US$) of Heavily indebted poor countries in 2009 and the Trade (in US$) of El Salvador in 2012?
Provide a succinct answer. 1.32e+11. What is the difference between the Trade (in US$) in Heavily indebted poor countries in 2009 and the Trade (in US$) in Jordan in 2012?
Provide a succinct answer. 1.19e+11. What is the difference between the Trade (in US$) of Heavily indebted poor countries in 2009 and the Trade (in US$) of Moldova in 2012?
Make the answer very short. 1.36e+11. What is the difference between the Trade (in US$) in El Salvador in 2009 and the Trade (in US$) in Jordan in 2012?
Provide a succinct answer. -1.50e+1. What is the difference between the Trade (in US$) in El Salvador in 2009 and the Trade (in US$) in Moldova in 2012?
Your answer should be very brief. 1.88e+09. What is the difference between the Trade (in US$) in Jordan in 2009 and the Trade (in US$) in Moldova in 2012?
Your answer should be very brief. 1.03e+1. What is the difference between the Trade (in US$) in Heavily indebted poor countries in 2009 and the Trade (in US$) in El Salvador in 2013?
Give a very brief answer. 1.31e+11. What is the difference between the Trade (in US$) in Heavily indebted poor countries in 2009 and the Trade (in US$) in Jordan in 2013?
Offer a terse response. 1.18e+11. What is the difference between the Trade (in US$) in Heavily indebted poor countries in 2009 and the Trade (in US$) in Moldova in 2013?
Offer a very short reply. 1.36e+11. What is the difference between the Trade (in US$) in El Salvador in 2009 and the Trade (in US$) in Jordan in 2013?
Give a very brief answer. -1.62e+1. What is the difference between the Trade (in US$) of El Salvador in 2009 and the Trade (in US$) of Moldova in 2013?
Make the answer very short. 1.55e+09. What is the difference between the Trade (in US$) of Jordan in 2009 and the Trade (in US$) of Moldova in 2013?
Provide a succinct answer. 1.00e+1. What is the difference between the Trade (in US$) of Heavily indebted poor countries in 2010 and the Trade (in US$) of El Salvador in 2011?
Keep it short and to the point. 1.60e+11. What is the difference between the Trade (in US$) of Heavily indebted poor countries in 2010 and the Trade (in US$) of Jordan in 2011?
Your answer should be very brief. 1.50e+11. What is the difference between the Trade (in US$) of Heavily indebted poor countries in 2010 and the Trade (in US$) of Moldova in 2011?
Your response must be concise. 1.65e+11. What is the difference between the Trade (in US$) in El Salvador in 2010 and the Trade (in US$) in Jordan in 2011?
Keep it short and to the point. -1.21e+1. What is the difference between the Trade (in US$) in El Salvador in 2010 and the Trade (in US$) in Moldova in 2011?
Make the answer very short. 3.16e+09. What is the difference between the Trade (in US$) in Jordan in 2010 and the Trade (in US$) in Moldova in 2011?
Ensure brevity in your answer.  1.22e+1. What is the difference between the Trade (in US$) in Heavily indebted poor countries in 2010 and the Trade (in US$) in El Salvador in 2012?
Make the answer very short. 1.60e+11. What is the difference between the Trade (in US$) of Heavily indebted poor countries in 2010 and the Trade (in US$) of Jordan in 2012?
Keep it short and to the point. 1.48e+11. What is the difference between the Trade (in US$) of Heavily indebted poor countries in 2010 and the Trade (in US$) of Moldova in 2012?
Ensure brevity in your answer.  1.65e+11. What is the difference between the Trade (in US$) of El Salvador in 2010 and the Trade (in US$) of Jordan in 2012?
Keep it short and to the point. -1.38e+1. What is the difference between the Trade (in US$) of El Salvador in 2010 and the Trade (in US$) of Moldova in 2012?
Make the answer very short. 3.06e+09. What is the difference between the Trade (in US$) in Jordan in 2010 and the Trade (in US$) in Moldova in 2012?
Your answer should be very brief. 1.21e+1. What is the difference between the Trade (in US$) of Heavily indebted poor countries in 2010 and the Trade (in US$) of El Salvador in 2013?
Offer a terse response. 1.60e+11. What is the difference between the Trade (in US$) of Heavily indebted poor countries in 2010 and the Trade (in US$) of Jordan in 2013?
Give a very brief answer. 1.47e+11. What is the difference between the Trade (in US$) in Heavily indebted poor countries in 2010 and the Trade (in US$) in Moldova in 2013?
Offer a very short reply. 1.65e+11. What is the difference between the Trade (in US$) of El Salvador in 2010 and the Trade (in US$) of Jordan in 2013?
Keep it short and to the point. -1.50e+1. What is the difference between the Trade (in US$) in El Salvador in 2010 and the Trade (in US$) in Moldova in 2013?
Provide a short and direct response. 2.74e+09. What is the difference between the Trade (in US$) of Jordan in 2010 and the Trade (in US$) of Moldova in 2013?
Offer a terse response. 1.18e+1. What is the difference between the Trade (in US$) of Heavily indebted poor countries in 2011 and the Trade (in US$) of El Salvador in 2012?
Offer a terse response. 1.92e+11. What is the difference between the Trade (in US$) of Heavily indebted poor countries in 2011 and the Trade (in US$) of Jordan in 2012?
Offer a terse response. 1.80e+11. What is the difference between the Trade (in US$) in Heavily indebted poor countries in 2011 and the Trade (in US$) in Moldova in 2012?
Your answer should be compact. 1.96e+11. What is the difference between the Trade (in US$) of El Salvador in 2011 and the Trade (in US$) of Jordan in 2012?
Keep it short and to the point. -1.22e+1. What is the difference between the Trade (in US$) of El Salvador in 2011 and the Trade (in US$) of Moldova in 2012?
Offer a very short reply. 4.68e+09. What is the difference between the Trade (in US$) of Jordan in 2011 and the Trade (in US$) of Moldova in 2012?
Provide a succinct answer. 1.52e+1. What is the difference between the Trade (in US$) in Heavily indebted poor countries in 2011 and the Trade (in US$) in El Salvador in 2013?
Offer a very short reply. 1.91e+11. What is the difference between the Trade (in US$) in Heavily indebted poor countries in 2011 and the Trade (in US$) in Jordan in 2013?
Make the answer very short. 1.78e+11. What is the difference between the Trade (in US$) of Heavily indebted poor countries in 2011 and the Trade (in US$) of Moldova in 2013?
Give a very brief answer. 1.96e+11. What is the difference between the Trade (in US$) in El Salvador in 2011 and the Trade (in US$) in Jordan in 2013?
Your response must be concise. -1.34e+1. What is the difference between the Trade (in US$) in El Salvador in 2011 and the Trade (in US$) in Moldova in 2013?
Provide a succinct answer. 4.36e+09. What is the difference between the Trade (in US$) in Jordan in 2011 and the Trade (in US$) in Moldova in 2013?
Your answer should be compact. 1.49e+1. What is the difference between the Trade (in US$) of Heavily indebted poor countries in 2012 and the Trade (in US$) of El Salvador in 2013?
Offer a very short reply. 2.12e+11. What is the difference between the Trade (in US$) in Heavily indebted poor countries in 2012 and the Trade (in US$) in Jordan in 2013?
Ensure brevity in your answer.  1.99e+11. What is the difference between the Trade (in US$) in Heavily indebted poor countries in 2012 and the Trade (in US$) in Moldova in 2013?
Give a very brief answer. 2.17e+11. What is the difference between the Trade (in US$) of El Salvador in 2012 and the Trade (in US$) of Jordan in 2013?
Provide a short and direct response. -1.37e+1. What is the difference between the Trade (in US$) of El Salvador in 2012 and the Trade (in US$) of Moldova in 2013?
Offer a very short reply. 4.06e+09. What is the difference between the Trade (in US$) of Jordan in 2012 and the Trade (in US$) of Moldova in 2013?
Make the answer very short. 1.65e+1. What is the average Trade (in US$) in Heavily indebted poor countries per year?
Your response must be concise. 1.73e+11. What is the average Trade (in US$) of El Salvador per year?
Your answer should be very brief. 9.81e+09. What is the average Trade (in US$) of Jordan per year?
Give a very brief answer. 1.89e+1. What is the average Trade (in US$) in Moldova per year?
Your response must be concise. 5.03e+09. In the year 2006, what is the difference between the Trade (in US$) of Heavily indebted poor countries and Trade (in US$) of El Salvador?
Offer a very short reply. 1.01e+11. In the year 2006, what is the difference between the Trade (in US$) in Heavily indebted poor countries and Trade (in US$) in Jordan?
Offer a very short reply. 9.63e+1. In the year 2006, what is the difference between the Trade (in US$) of Heavily indebted poor countries and Trade (in US$) of Moldova?
Provide a succinct answer. 1.06e+11. In the year 2006, what is the difference between the Trade (in US$) of El Salvador and Trade (in US$) of Jordan?
Your answer should be very brief. -4.67e+09. In the year 2006, what is the difference between the Trade (in US$) of El Salvador and Trade (in US$) of Moldova?
Offer a terse response. 5.43e+09. In the year 2006, what is the difference between the Trade (in US$) in Jordan and Trade (in US$) in Moldova?
Offer a very short reply. 1.01e+1. In the year 2007, what is the difference between the Trade (in US$) of Heavily indebted poor countries and Trade (in US$) of El Salvador?
Give a very brief answer. 1.24e+11. In the year 2007, what is the difference between the Trade (in US$) in Heavily indebted poor countries and Trade (in US$) in Jordan?
Keep it short and to the point. 1.18e+11. In the year 2007, what is the difference between the Trade (in US$) of Heavily indebted poor countries and Trade (in US$) of Moldova?
Provide a short and direct response. 1.29e+11. In the year 2007, what is the difference between the Trade (in US$) in El Salvador and Trade (in US$) in Jordan?
Make the answer very short. -5.99e+09. In the year 2007, what is the difference between the Trade (in US$) of El Salvador and Trade (in US$) of Moldova?
Give a very brief answer. 5.43e+09. In the year 2007, what is the difference between the Trade (in US$) in Jordan and Trade (in US$) in Moldova?
Provide a short and direct response. 1.14e+1. In the year 2008, what is the difference between the Trade (in US$) in Heavily indebted poor countries and Trade (in US$) in El Salvador?
Your answer should be compact. 1.49e+11. In the year 2008, what is the difference between the Trade (in US$) of Heavily indebted poor countries and Trade (in US$) of Jordan?
Offer a very short reply. 1.41e+11. In the year 2008, what is the difference between the Trade (in US$) in Heavily indebted poor countries and Trade (in US$) in Moldova?
Ensure brevity in your answer.  1.54e+11. In the year 2008, what is the difference between the Trade (in US$) of El Salvador and Trade (in US$) of Jordan?
Offer a very short reply. -8.58e+09. In the year 2008, what is the difference between the Trade (in US$) of El Salvador and Trade (in US$) of Moldova?
Ensure brevity in your answer.  4.98e+09. In the year 2008, what is the difference between the Trade (in US$) of Jordan and Trade (in US$) of Moldova?
Your answer should be compact. 1.36e+1. In the year 2009, what is the difference between the Trade (in US$) of Heavily indebted poor countries and Trade (in US$) of El Salvador?
Provide a succinct answer. 1.34e+11. In the year 2009, what is the difference between the Trade (in US$) in Heavily indebted poor countries and Trade (in US$) in Jordan?
Make the answer very short. 1.26e+11. In the year 2009, what is the difference between the Trade (in US$) of Heavily indebted poor countries and Trade (in US$) of Moldova?
Give a very brief answer. 1.38e+11. In the year 2009, what is the difference between the Trade (in US$) in El Salvador and Trade (in US$) in Jordan?
Your answer should be very brief. -8.46e+09. In the year 2009, what is the difference between the Trade (in US$) in El Salvador and Trade (in US$) in Moldova?
Ensure brevity in your answer.  3.99e+09. In the year 2009, what is the difference between the Trade (in US$) of Jordan and Trade (in US$) of Moldova?
Offer a terse response. 1.25e+1. In the year 2010, what is the difference between the Trade (in US$) of Heavily indebted poor countries and Trade (in US$) of El Salvador?
Your answer should be compact. 1.62e+11. In the year 2010, what is the difference between the Trade (in US$) in Heavily indebted poor countries and Trade (in US$) in Jordan?
Make the answer very short. 1.53e+11. In the year 2010, what is the difference between the Trade (in US$) in Heavily indebted poor countries and Trade (in US$) in Moldova?
Keep it short and to the point. 1.66e+11. In the year 2010, what is the difference between the Trade (in US$) in El Salvador and Trade (in US$) in Jordan?
Provide a succinct answer. -9.06e+09. In the year 2010, what is the difference between the Trade (in US$) in El Salvador and Trade (in US$) in Moldova?
Your answer should be compact. 4.61e+09. In the year 2010, what is the difference between the Trade (in US$) of Jordan and Trade (in US$) of Moldova?
Make the answer very short. 1.37e+1. In the year 2011, what is the difference between the Trade (in US$) of Heavily indebted poor countries and Trade (in US$) of El Salvador?
Offer a terse response. 1.92e+11. In the year 2011, what is the difference between the Trade (in US$) in Heavily indebted poor countries and Trade (in US$) in Jordan?
Your answer should be very brief. 1.81e+11. In the year 2011, what is the difference between the Trade (in US$) of Heavily indebted poor countries and Trade (in US$) of Moldova?
Offer a very short reply. 1.96e+11. In the year 2011, what is the difference between the Trade (in US$) in El Salvador and Trade (in US$) in Jordan?
Offer a very short reply. -1.05e+1. In the year 2011, what is the difference between the Trade (in US$) of El Salvador and Trade (in US$) of Moldova?
Offer a terse response. 4.78e+09. In the year 2011, what is the difference between the Trade (in US$) of Jordan and Trade (in US$) of Moldova?
Offer a terse response. 1.53e+1. In the year 2012, what is the difference between the Trade (in US$) in Heavily indebted poor countries and Trade (in US$) in El Salvador?
Give a very brief answer. 2.13e+11. In the year 2012, what is the difference between the Trade (in US$) in Heavily indebted poor countries and Trade (in US$) in Jordan?
Your answer should be compact. 2.00e+11. In the year 2012, what is the difference between the Trade (in US$) of Heavily indebted poor countries and Trade (in US$) of Moldova?
Give a very brief answer. 2.17e+11. In the year 2012, what is the difference between the Trade (in US$) in El Salvador and Trade (in US$) in Jordan?
Offer a terse response. -1.25e+1. In the year 2012, what is the difference between the Trade (in US$) of El Salvador and Trade (in US$) of Moldova?
Your answer should be compact. 4.38e+09. In the year 2012, what is the difference between the Trade (in US$) of Jordan and Trade (in US$) of Moldova?
Offer a terse response. 1.69e+1. In the year 2013, what is the difference between the Trade (in US$) of Heavily indebted poor countries and Trade (in US$) of El Salvador?
Your response must be concise. 2.28e+11. In the year 2013, what is the difference between the Trade (in US$) of Heavily indebted poor countries and Trade (in US$) of Jordan?
Ensure brevity in your answer.  2.14e+11. In the year 2013, what is the difference between the Trade (in US$) of Heavily indebted poor countries and Trade (in US$) of Moldova?
Your response must be concise. 2.32e+11. In the year 2013, what is the difference between the Trade (in US$) in El Salvador and Trade (in US$) in Jordan?
Offer a very short reply. -1.31e+1. In the year 2013, what is the difference between the Trade (in US$) in El Salvador and Trade (in US$) in Moldova?
Offer a terse response. 4.66e+09. In the year 2013, what is the difference between the Trade (in US$) in Jordan and Trade (in US$) in Moldova?
Your answer should be very brief. 1.77e+1. What is the ratio of the Trade (in US$) in Heavily indebted poor countries in 2006 to that in 2007?
Offer a very short reply. 0.82. What is the ratio of the Trade (in US$) in El Salvador in 2006 to that in 2007?
Keep it short and to the point. 0.88. What is the ratio of the Trade (in US$) in Jordan in 2006 to that in 2007?
Provide a succinct answer. 0.84. What is the ratio of the Trade (in US$) in Moldova in 2006 to that in 2007?
Give a very brief answer. 0.73. What is the ratio of the Trade (in US$) of Heavily indebted poor countries in 2006 to that in 2008?
Your response must be concise. 0.68. What is the ratio of the Trade (in US$) of El Salvador in 2006 to that in 2008?
Offer a terse response. 0.8. What is the ratio of the Trade (in US$) of Jordan in 2006 to that in 2008?
Your response must be concise. 0.69. What is the ratio of the Trade (in US$) of Moldova in 2006 to that in 2008?
Offer a terse response. 0.55. What is the ratio of the Trade (in US$) in Heavily indebted poor countries in 2006 to that in 2009?
Your answer should be compact. 0.77. What is the ratio of the Trade (in US$) of El Salvador in 2006 to that in 2009?
Your answer should be compact. 1.07. What is the ratio of the Trade (in US$) in Jordan in 2006 to that in 2009?
Ensure brevity in your answer.  0.8. What is the ratio of the Trade (in US$) in Moldova in 2006 to that in 2009?
Ensure brevity in your answer.  0.78. What is the ratio of the Trade (in US$) of Heavily indebted poor countries in 2006 to that in 2010?
Make the answer very short. 0.64. What is the ratio of the Trade (in US$) in Jordan in 2006 to that in 2010?
Provide a succinct answer. 0.73. What is the ratio of the Trade (in US$) in Moldova in 2006 to that in 2010?
Your answer should be compact. 0.69. What is the ratio of the Trade (in US$) in Heavily indebted poor countries in 2006 to that in 2011?
Your answer should be very brief. 0.54. What is the ratio of the Trade (in US$) of El Salvador in 2006 to that in 2011?
Your response must be concise. 0.79. What is the ratio of the Trade (in US$) in Jordan in 2006 to that in 2011?
Offer a terse response. 0.62. What is the ratio of the Trade (in US$) of Moldova in 2006 to that in 2011?
Make the answer very short. 0.52. What is the ratio of the Trade (in US$) of Heavily indebted poor countries in 2006 to that in 2012?
Keep it short and to the point. 0.49. What is the ratio of the Trade (in US$) in El Salvador in 2006 to that in 2012?
Your response must be concise. 0.82. What is the ratio of the Trade (in US$) in Jordan in 2006 to that in 2012?
Give a very brief answer. 0.58. What is the ratio of the Trade (in US$) of Moldova in 2006 to that in 2012?
Your response must be concise. 0.51. What is the ratio of the Trade (in US$) in Heavily indebted poor countries in 2006 to that in 2013?
Your answer should be very brief. 0.46. What is the ratio of the Trade (in US$) of El Salvador in 2006 to that in 2013?
Your answer should be very brief. 0.77. What is the ratio of the Trade (in US$) in Jordan in 2006 to that in 2013?
Offer a terse response. 0.55. What is the ratio of the Trade (in US$) of Moldova in 2006 to that in 2013?
Your answer should be very brief. 0.49. What is the ratio of the Trade (in US$) of Heavily indebted poor countries in 2007 to that in 2008?
Your answer should be compact. 0.83. What is the ratio of the Trade (in US$) in El Salvador in 2007 to that in 2008?
Ensure brevity in your answer.  0.91. What is the ratio of the Trade (in US$) in Jordan in 2007 to that in 2008?
Your response must be concise. 0.82. What is the ratio of the Trade (in US$) of Moldova in 2007 to that in 2008?
Make the answer very short. 0.75. What is the ratio of the Trade (in US$) in Heavily indebted poor countries in 2007 to that in 2009?
Give a very brief answer. 0.94. What is the ratio of the Trade (in US$) of El Salvador in 2007 to that in 2009?
Ensure brevity in your answer.  1.22. What is the ratio of the Trade (in US$) of Jordan in 2007 to that in 2009?
Your answer should be compact. 0.95. What is the ratio of the Trade (in US$) of Moldova in 2007 to that in 2009?
Make the answer very short. 1.07. What is the ratio of the Trade (in US$) of Heavily indebted poor countries in 2007 to that in 2010?
Your answer should be very brief. 0.78. What is the ratio of the Trade (in US$) in El Salvador in 2007 to that in 2010?
Provide a short and direct response. 1.06. What is the ratio of the Trade (in US$) of Jordan in 2007 to that in 2010?
Ensure brevity in your answer.  0.86. What is the ratio of the Trade (in US$) in Moldova in 2007 to that in 2010?
Provide a short and direct response. 0.94. What is the ratio of the Trade (in US$) in Heavily indebted poor countries in 2007 to that in 2011?
Provide a short and direct response. 0.66. What is the ratio of the Trade (in US$) of El Salvador in 2007 to that in 2011?
Your answer should be very brief. 0.9. What is the ratio of the Trade (in US$) of Jordan in 2007 to that in 2011?
Give a very brief answer. 0.74. What is the ratio of the Trade (in US$) in Moldova in 2007 to that in 2011?
Offer a very short reply. 0.71. What is the ratio of the Trade (in US$) of Heavily indebted poor countries in 2007 to that in 2012?
Keep it short and to the point. 0.6. What is the ratio of the Trade (in US$) of El Salvador in 2007 to that in 2012?
Keep it short and to the point. 0.93. What is the ratio of the Trade (in US$) in Jordan in 2007 to that in 2012?
Provide a succinct answer. 0.68. What is the ratio of the Trade (in US$) in Moldova in 2007 to that in 2012?
Offer a very short reply. 0.7. What is the ratio of the Trade (in US$) in Heavily indebted poor countries in 2007 to that in 2013?
Your answer should be very brief. 0.56. What is the ratio of the Trade (in US$) of El Salvador in 2007 to that in 2013?
Your answer should be compact. 0.87. What is the ratio of the Trade (in US$) in Jordan in 2007 to that in 2013?
Ensure brevity in your answer.  0.65. What is the ratio of the Trade (in US$) in Moldova in 2007 to that in 2013?
Your answer should be compact. 0.66. What is the ratio of the Trade (in US$) in Heavily indebted poor countries in 2008 to that in 2009?
Your answer should be compact. 1.12. What is the ratio of the Trade (in US$) of El Salvador in 2008 to that in 2009?
Ensure brevity in your answer.  1.33. What is the ratio of the Trade (in US$) in Jordan in 2008 to that in 2009?
Offer a terse response. 1.17. What is the ratio of the Trade (in US$) of Moldova in 2008 to that in 2009?
Your answer should be compact. 1.42. What is the ratio of the Trade (in US$) of Heavily indebted poor countries in 2008 to that in 2010?
Provide a succinct answer. 0.94. What is the ratio of the Trade (in US$) in El Salvador in 2008 to that in 2010?
Your answer should be compact. 1.16. What is the ratio of the Trade (in US$) of Jordan in 2008 to that in 2010?
Provide a short and direct response. 1.05. What is the ratio of the Trade (in US$) in Moldova in 2008 to that in 2010?
Your response must be concise. 1.24. What is the ratio of the Trade (in US$) of Heavily indebted poor countries in 2008 to that in 2011?
Your answer should be compact. 0.79. What is the ratio of the Trade (in US$) of El Salvador in 2008 to that in 2011?
Make the answer very short. 0.99. What is the ratio of the Trade (in US$) of Jordan in 2008 to that in 2011?
Give a very brief answer. 0.9. What is the ratio of the Trade (in US$) in Moldova in 2008 to that in 2011?
Provide a succinct answer. 0.94. What is the ratio of the Trade (in US$) of Heavily indebted poor countries in 2008 to that in 2012?
Your answer should be very brief. 0.72. What is the ratio of the Trade (in US$) of El Salvador in 2008 to that in 2012?
Your answer should be very brief. 1.01. What is the ratio of the Trade (in US$) in Jordan in 2008 to that in 2012?
Offer a terse response. 0.84. What is the ratio of the Trade (in US$) in Moldova in 2008 to that in 2012?
Provide a short and direct response. 0.93. What is the ratio of the Trade (in US$) in Heavily indebted poor countries in 2008 to that in 2013?
Your answer should be very brief. 0.67. What is the ratio of the Trade (in US$) in El Salvador in 2008 to that in 2013?
Offer a terse response. 0.96. What is the ratio of the Trade (in US$) in Jordan in 2008 to that in 2013?
Offer a terse response. 0.8. What is the ratio of the Trade (in US$) in Moldova in 2008 to that in 2013?
Your answer should be very brief. 0.88. What is the ratio of the Trade (in US$) in Heavily indebted poor countries in 2009 to that in 2010?
Offer a terse response. 0.83. What is the ratio of the Trade (in US$) in El Salvador in 2009 to that in 2010?
Give a very brief answer. 0.87. What is the ratio of the Trade (in US$) of Jordan in 2009 to that in 2010?
Offer a very short reply. 0.9. What is the ratio of the Trade (in US$) of Moldova in 2009 to that in 2010?
Keep it short and to the point. 0.88. What is the ratio of the Trade (in US$) of Heavily indebted poor countries in 2009 to that in 2011?
Your answer should be very brief. 0.7. What is the ratio of the Trade (in US$) in El Salvador in 2009 to that in 2011?
Make the answer very short. 0.74. What is the ratio of the Trade (in US$) in Jordan in 2009 to that in 2011?
Your answer should be very brief. 0.77. What is the ratio of the Trade (in US$) in Moldova in 2009 to that in 2011?
Your response must be concise. 0.66. What is the ratio of the Trade (in US$) in Heavily indebted poor countries in 2009 to that in 2012?
Your response must be concise. 0.64. What is the ratio of the Trade (in US$) of El Salvador in 2009 to that in 2012?
Provide a short and direct response. 0.76. What is the ratio of the Trade (in US$) of Jordan in 2009 to that in 2012?
Ensure brevity in your answer.  0.72. What is the ratio of the Trade (in US$) of Moldova in 2009 to that in 2012?
Your answer should be compact. 0.65. What is the ratio of the Trade (in US$) of Heavily indebted poor countries in 2009 to that in 2013?
Make the answer very short. 0.6. What is the ratio of the Trade (in US$) of El Salvador in 2009 to that in 2013?
Make the answer very short. 0.72. What is the ratio of the Trade (in US$) of Jordan in 2009 to that in 2013?
Your answer should be very brief. 0.68. What is the ratio of the Trade (in US$) in Moldova in 2009 to that in 2013?
Make the answer very short. 0.62. What is the ratio of the Trade (in US$) of Heavily indebted poor countries in 2010 to that in 2011?
Your answer should be very brief. 0.84. What is the ratio of the Trade (in US$) of El Salvador in 2010 to that in 2011?
Your response must be concise. 0.85. What is the ratio of the Trade (in US$) of Jordan in 2010 to that in 2011?
Ensure brevity in your answer.  0.86. What is the ratio of the Trade (in US$) in Moldova in 2010 to that in 2011?
Your response must be concise. 0.76. What is the ratio of the Trade (in US$) of Heavily indebted poor countries in 2010 to that in 2012?
Your response must be concise. 0.77. What is the ratio of the Trade (in US$) of El Salvador in 2010 to that in 2012?
Provide a succinct answer. 0.87. What is the ratio of the Trade (in US$) of Jordan in 2010 to that in 2012?
Ensure brevity in your answer.  0.79. What is the ratio of the Trade (in US$) in Moldova in 2010 to that in 2012?
Make the answer very short. 0.75. What is the ratio of the Trade (in US$) in Heavily indebted poor countries in 2010 to that in 2013?
Give a very brief answer. 0.72. What is the ratio of the Trade (in US$) of El Salvador in 2010 to that in 2013?
Offer a terse response. 0.83. What is the ratio of the Trade (in US$) in Jordan in 2010 to that in 2013?
Offer a terse response. 0.75. What is the ratio of the Trade (in US$) of Moldova in 2010 to that in 2013?
Provide a short and direct response. 0.71. What is the ratio of the Trade (in US$) of Heavily indebted poor countries in 2011 to that in 2012?
Keep it short and to the point. 0.91. What is the ratio of the Trade (in US$) of El Salvador in 2011 to that in 2012?
Ensure brevity in your answer.  1.03. What is the ratio of the Trade (in US$) in Jordan in 2011 to that in 2012?
Ensure brevity in your answer.  0.93. What is the ratio of the Trade (in US$) of Moldova in 2011 to that in 2012?
Offer a very short reply. 0.98. What is the ratio of the Trade (in US$) in Heavily indebted poor countries in 2011 to that in 2013?
Give a very brief answer. 0.85. What is the ratio of the Trade (in US$) of El Salvador in 2011 to that in 2013?
Ensure brevity in your answer.  0.97. What is the ratio of the Trade (in US$) of Jordan in 2011 to that in 2013?
Offer a terse response. 0.88. What is the ratio of the Trade (in US$) in Moldova in 2011 to that in 2013?
Provide a short and direct response. 0.94. What is the ratio of the Trade (in US$) of Heavily indebted poor countries in 2012 to that in 2013?
Offer a terse response. 0.94. What is the ratio of the Trade (in US$) of El Salvador in 2012 to that in 2013?
Offer a terse response. 0.95. What is the ratio of the Trade (in US$) in Jordan in 2012 to that in 2013?
Ensure brevity in your answer.  0.95. What is the ratio of the Trade (in US$) in Moldova in 2012 to that in 2013?
Provide a short and direct response. 0.95. What is the difference between the highest and the second highest Trade (in US$) in Heavily indebted poor countries?
Your answer should be compact. 1.52e+1. What is the difference between the highest and the second highest Trade (in US$) of El Salvador?
Your answer should be very brief. 3.01e+08. What is the difference between the highest and the second highest Trade (in US$) of Jordan?
Make the answer very short. 1.20e+09. What is the difference between the highest and the second highest Trade (in US$) of Moldova?
Your answer should be very brief. 3.21e+08. What is the difference between the highest and the lowest Trade (in US$) in Heavily indebted poor countries?
Keep it short and to the point. 1.29e+11. What is the difference between the highest and the lowest Trade (in US$) in El Salvador?
Your answer should be compact. 3.11e+09. What is the difference between the highest and the lowest Trade (in US$) of Jordan?
Provide a short and direct response. 1.09e+1. What is the difference between the highest and the lowest Trade (in US$) in Moldova?
Keep it short and to the point. 3.30e+09. 